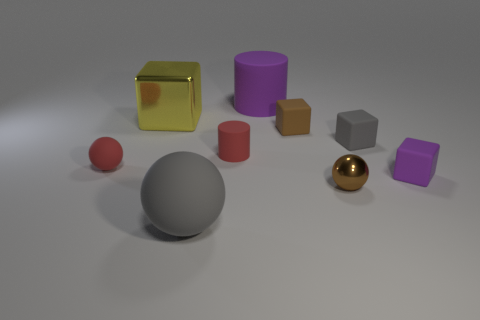Subtract all small balls. How many balls are left? 1 Add 6 tiny green metallic blocks. How many tiny green metallic blocks exist? 6 Add 1 small objects. How many objects exist? 10 Subtract all red spheres. How many spheres are left? 2 Subtract 0 yellow spheres. How many objects are left? 9 Subtract all balls. How many objects are left? 6 Subtract 3 blocks. How many blocks are left? 1 Subtract all blue cubes. Subtract all brown balls. How many cubes are left? 4 Subtract all brown balls. How many blue cylinders are left? 0 Subtract all gray rubber things. Subtract all cylinders. How many objects are left? 5 